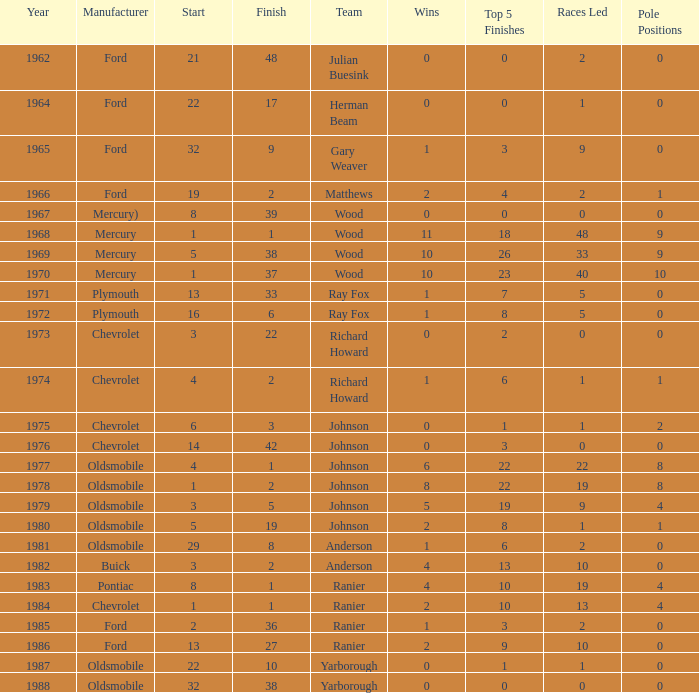What is the least finish duration for a race where the commencement was lesser than 3, buick was the manufacturer, and the racing event happened subsequent to 1978? None. 